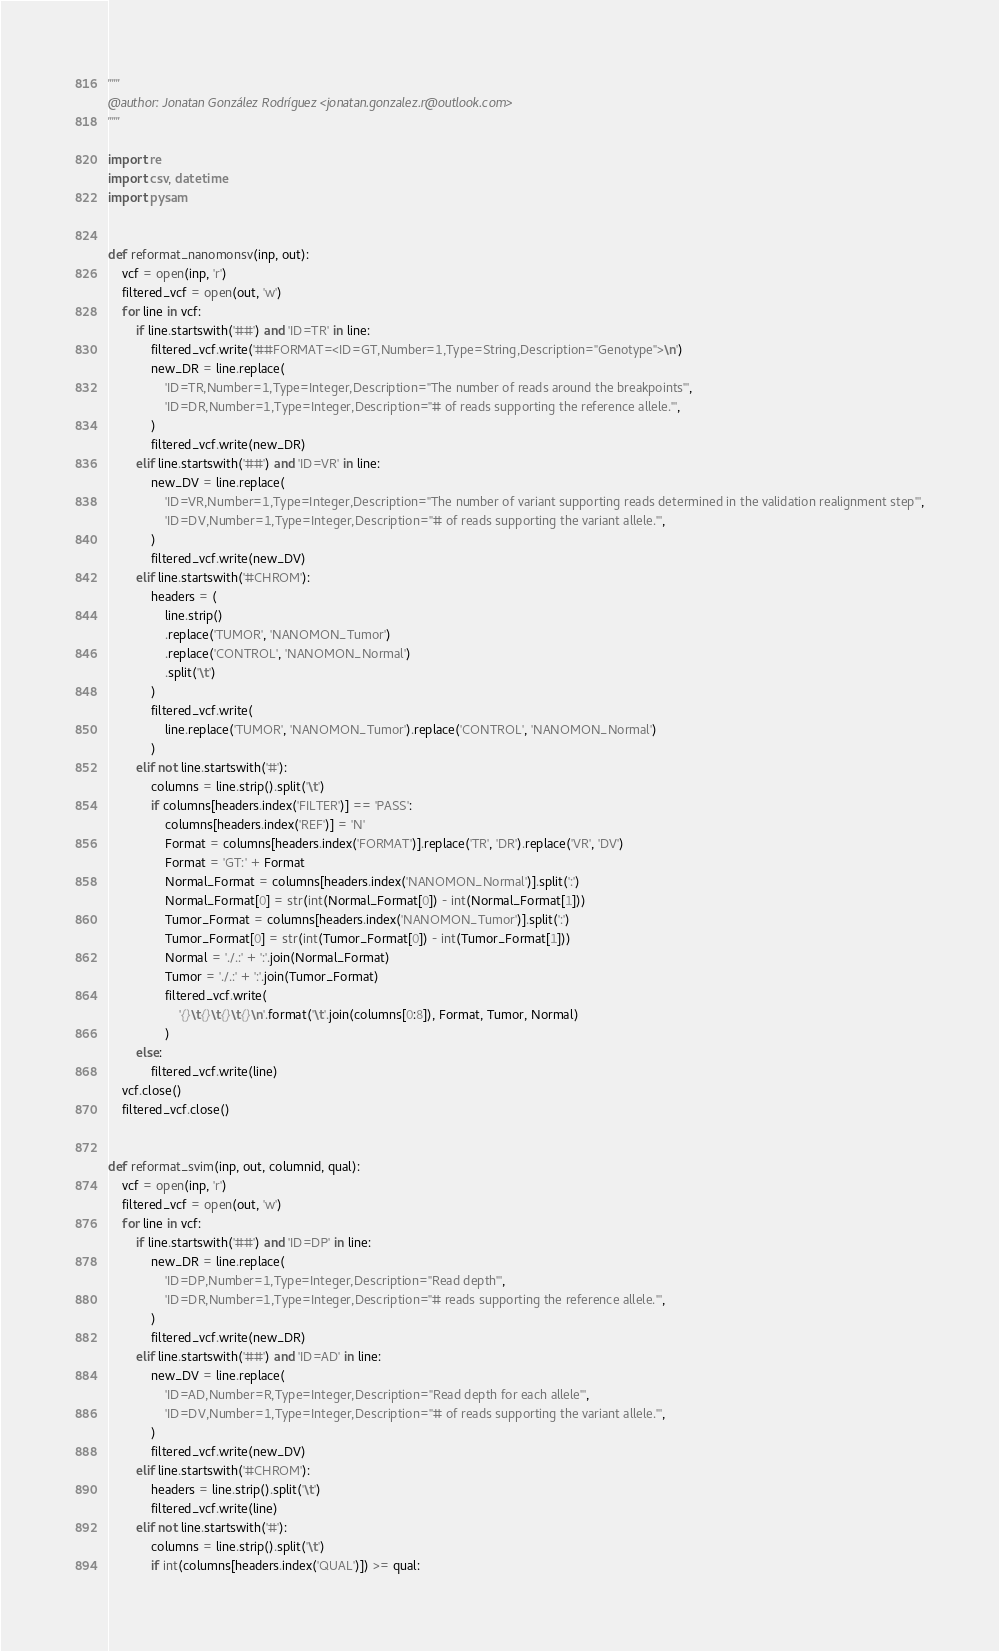<code> <loc_0><loc_0><loc_500><loc_500><_Python_>"""
@author: Jonatan González Rodríguez <jonatan.gonzalez.r@outlook.com>
"""

import re
import csv, datetime
import pysam


def reformat_nanomonsv(inp, out):
    vcf = open(inp, 'r')
    filtered_vcf = open(out, 'w')
    for line in vcf:
        if line.startswith('##') and 'ID=TR' in line:
            filtered_vcf.write('##FORMAT=<ID=GT,Number=1,Type=String,Description="Genotype">\n')
            new_DR = line.replace(
                'ID=TR,Number=1,Type=Integer,Description="The number of reads around the breakpoints"',
                'ID=DR,Number=1,Type=Integer,Description="# of reads supporting the reference allele."',
            )
            filtered_vcf.write(new_DR)
        elif line.startswith('##') and 'ID=VR' in line:
            new_DV = line.replace(
                'ID=VR,Number=1,Type=Integer,Description="The number of variant supporting reads determined in the validation realignment step"',
                'ID=DV,Number=1,Type=Integer,Description="# of reads supporting the variant allele."',
            )
            filtered_vcf.write(new_DV)
        elif line.startswith('#CHROM'):
            headers = (
                line.strip()
                .replace('TUMOR', 'NANOMON_Tumor')
                .replace('CONTROL', 'NANOMON_Normal')
                .split('\t')
            )
            filtered_vcf.write(
                line.replace('TUMOR', 'NANOMON_Tumor').replace('CONTROL', 'NANOMON_Normal')
            )
        elif not line.startswith('#'):
            columns = line.strip().split('\t')
            if columns[headers.index('FILTER')] == 'PASS':
                columns[headers.index('REF')] = 'N'
                Format = columns[headers.index('FORMAT')].replace('TR', 'DR').replace('VR', 'DV')
                Format = 'GT:' + Format
                Normal_Format = columns[headers.index('NANOMON_Normal')].split(':')
                Normal_Format[0] = str(int(Normal_Format[0]) - int(Normal_Format[1]))
                Tumor_Format = columns[headers.index('NANOMON_Tumor')].split(':')
                Tumor_Format[0] = str(int(Tumor_Format[0]) - int(Tumor_Format[1]))
                Normal = './.:' + ':'.join(Normal_Format)
                Tumor = './.:' + ':'.join(Tumor_Format)
                filtered_vcf.write(
                    '{}\t{}\t{}\t{}\n'.format('\t'.join(columns[0:8]), Format, Tumor, Normal)
                )
        else:
            filtered_vcf.write(line)
    vcf.close()
    filtered_vcf.close()


def reformat_svim(inp, out, columnid, qual):
    vcf = open(inp, 'r')
    filtered_vcf = open(out, 'w')
    for line in vcf:
        if line.startswith('##') and 'ID=DP' in line:
            new_DR = line.replace(
                'ID=DP,Number=1,Type=Integer,Description="Read depth"',
                'ID=DR,Number=1,Type=Integer,Description="# reads supporting the reference allele."',
            )
            filtered_vcf.write(new_DR)
        elif line.startswith('##') and 'ID=AD' in line:
            new_DV = line.replace(
                'ID=AD,Number=R,Type=Integer,Description="Read depth for each allele"',
                'ID=DV,Number=1,Type=Integer,Description="# of reads supporting the variant allele."',
            )
            filtered_vcf.write(new_DV)
        elif line.startswith('#CHROM'):
            headers = line.strip().split('\t')
            filtered_vcf.write(line)
        elif not line.startswith('#'):
            columns = line.strip().split('\t')
            if int(columns[headers.index('QUAL')]) >= qual:</code> 